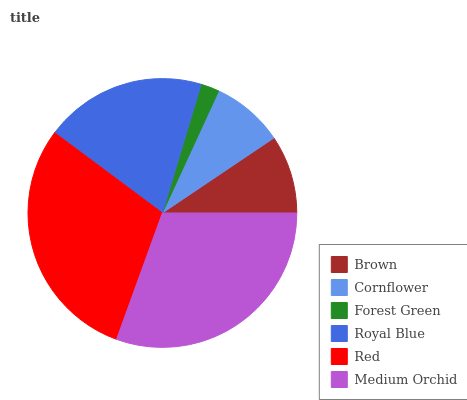Is Forest Green the minimum?
Answer yes or no. Yes. Is Medium Orchid the maximum?
Answer yes or no. Yes. Is Cornflower the minimum?
Answer yes or no. No. Is Cornflower the maximum?
Answer yes or no. No. Is Brown greater than Cornflower?
Answer yes or no. Yes. Is Cornflower less than Brown?
Answer yes or no. Yes. Is Cornflower greater than Brown?
Answer yes or no. No. Is Brown less than Cornflower?
Answer yes or no. No. Is Royal Blue the high median?
Answer yes or no. Yes. Is Brown the low median?
Answer yes or no. Yes. Is Medium Orchid the high median?
Answer yes or no. No. Is Cornflower the low median?
Answer yes or no. No. 